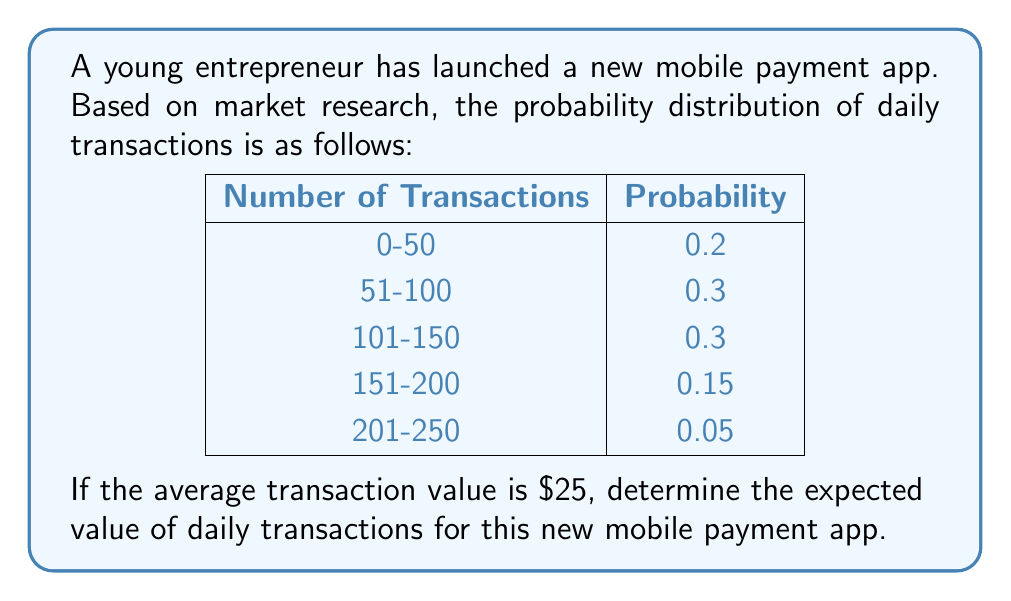Give your solution to this math problem. To solve this problem, we'll follow these steps:

1) First, we need to calculate the midpoint of each transaction range:
   0-50: (0 + 50) / 2 = 25
   51-100: (51 + 100) / 2 = 75.5
   101-150: (101 + 150) / 2 = 125.5
   151-200: (151 + 200) / 2 = 175.5
   201-250: (201 + 250) / 2 = 225.5

2) Now, we can set up our expected value calculation:
   $E(X) = \sum_{i=1}^{n} x_i \cdot p(x_i)$
   
   Where $x_i$ is the midpoint of each range, and $p(x_i)$ is its probability.

3) Let's calculate:
   $E(X) = 25 \cdot 0.2 + 75.5 \cdot 0.3 + 125.5 \cdot 0.3 + 175.5 \cdot 0.15 + 225.5 \cdot 0.05$
   
4) Simplifying:
   $E(X) = 5 + 22.65 + 37.65 + 26.325 + 11.275 = 102.9$

5) This gives us the expected number of daily transactions. To get the expected value in dollars, we multiply by the average transaction value:

   Expected Value = 102.9 * $25 = $2,572.50
Answer: $2,572.50 